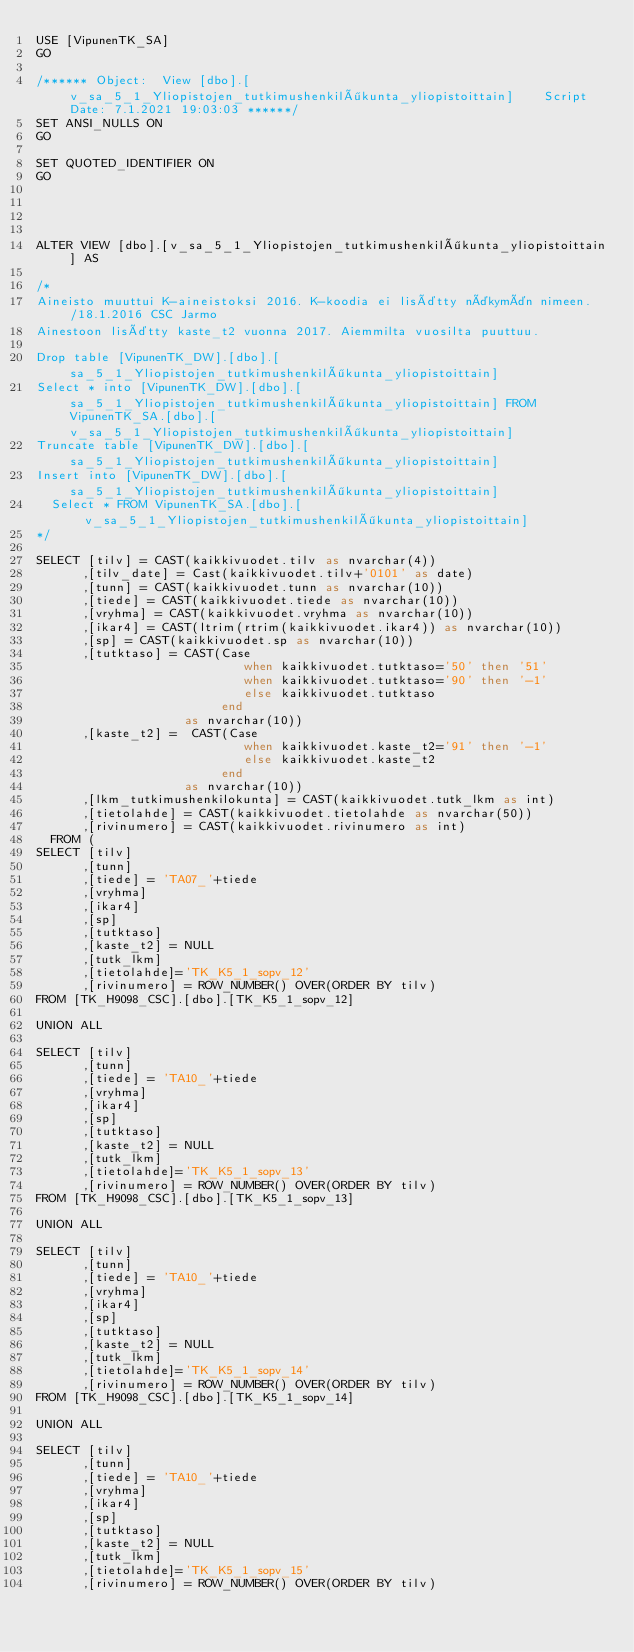<code> <loc_0><loc_0><loc_500><loc_500><_SQL_>USE [VipunenTK_SA]
GO

/****** Object:  View [dbo].[v_sa_5_1_Yliopistojen_tutkimushenkilökunta_yliopistoittain]    Script Date: 7.1.2021 19:03:03 ******/
SET ANSI_NULLS ON
GO

SET QUOTED_IDENTIFIER ON
GO




ALTER VIEW [dbo].[v_sa_5_1_Yliopistojen_tutkimushenkilökunta_yliopistoittain] AS

/*
Aineisto muuttui K-aineistoksi 2016. K-koodia ei lisätty näkymän nimeen. /18.1.2016 CSC Jarmo
Ainestoon lisätty kaste_t2 vuonna 2017. Aiemmilta vuosilta puuttuu.

Drop table [VipunenTK_DW].[dbo].[sa_5_1_Yliopistojen_tutkimushenkilökunta_yliopistoittain]
Select * into [VipunenTK_DW].[dbo].[sa_5_1_Yliopistojen_tutkimushenkilökunta_yliopistoittain] FROM VipunenTK_SA.[dbo].[v_sa_5_1_Yliopistojen_tutkimushenkilökunta_yliopistoittain]
Truncate table [VipunenTK_DW].[dbo].[sa_5_1_Yliopistojen_tutkimushenkilökunta_yliopistoittain]
Insert into [VipunenTK_DW].[dbo].[sa_5_1_Yliopistojen_tutkimushenkilökunta_yliopistoittain]
  Select * FROM VipunenTK_SA.[dbo].[v_sa_5_1_Yliopistojen_tutkimushenkilökunta_yliopistoittain]
*/

SELECT [tilv] = CAST(kaikkivuodet.tilv as nvarchar(4))
	  ,[tilv_date] = Cast(kaikkivuodet.tilv+'0101' as date)
      ,[tunn] = CAST(kaikkivuodet.tunn as nvarchar(10))
      ,[tiede] = CAST(kaikkivuodet.tiede as nvarchar(10))
      ,[vryhma] = CAST(kaikkivuodet.vryhma as nvarchar(10))
      ,[ikar4] = CAST(ltrim(rtrim(kaikkivuodet.ikar4)) as nvarchar(10))
      ,[sp] = CAST(kaikkivuodet.sp as nvarchar(10))
      ,[tutktaso] = CAST(Case 
							when kaikkivuodet.tutktaso='50' then '51'
							when kaikkivuodet.tutktaso='90' then '-1' 
							else kaikkivuodet.tutktaso 
						 end 
					as nvarchar(10))
	  ,[kaste_t2] =  CAST(Case 
							when kaikkivuodet.kaste_t2='91' then '-1' 
							else kaikkivuodet.kaste_t2 
						 end 
					as nvarchar(10))
      ,[lkm_tutkimushenkilokunta] = CAST(kaikkivuodet.tutk_lkm as int)
      ,[tietolahde] = CAST(kaikkivuodet.tietolahde as nvarchar(50))
      ,[rivinumero] = CAST(kaikkivuodet.rivinumero as int)
  FROM (
SELECT [tilv]
      ,[tunn]
      ,[tiede] = 'TA07_'+tiede
      ,[vryhma]
      ,[ikar4]
      ,[sp]
      ,[tutktaso]
	  ,[kaste_t2] = NULL
      ,[tutk_lkm]
      ,[tietolahde]='TK_K5_1_sopv_12'
      ,[rivinumero] = ROW_NUMBER() OVER(ORDER BY tilv)
FROM [TK_H9098_CSC].[dbo].[TK_K5_1_sopv_12]

UNION ALL

SELECT [tilv]
      ,[tunn]
      ,[tiede] = 'TA10_'+tiede
      ,[vryhma]
      ,[ikar4]
      ,[sp]
      ,[tutktaso]
	  ,[kaste_t2] = NULL
      ,[tutk_lkm]
      ,[tietolahde]='TK_K5_1_sopv_13'
      ,[rivinumero] = ROW_NUMBER() OVER(ORDER BY tilv)
FROM [TK_H9098_CSC].[dbo].[TK_K5_1_sopv_13]

UNION ALL

SELECT [tilv]
      ,[tunn]
      ,[tiede] = 'TA10_'+tiede
      ,[vryhma]
      ,[ikar4]
      ,[sp]
      ,[tutktaso]
	  ,[kaste_t2] = NULL
      ,[tutk_lkm]
      ,[tietolahde]='TK_K5_1_sopv_14'
      ,[rivinumero] = ROW_NUMBER() OVER(ORDER BY tilv)
FROM [TK_H9098_CSC].[dbo].[TK_K5_1_sopv_14]

UNION ALL

SELECT [tilv]
      ,[tunn]
      ,[tiede] = 'TA10_'+tiede
      ,[vryhma]
      ,[ikar4]
      ,[sp]
      ,[tutktaso]
	  ,[kaste_t2] = NULL
      ,[tutk_lkm]
      ,[tietolahde]='TK_K5_1_sopv_15'
      ,[rivinumero] = ROW_NUMBER() OVER(ORDER BY tilv)</code> 